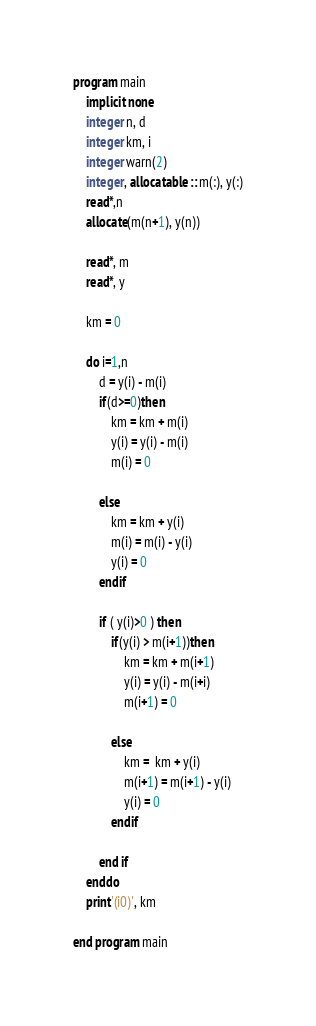<code> <loc_0><loc_0><loc_500><loc_500><_FORTRAN_>program main
    implicit none
    integer n, d
    integer km, i
    integer warn(2)
    integer, allocatable :: m(:), y(:)
    read*,n
    allocate(m(n+1), y(n))

    read*, m
    read*, y

    km = 0

    do i=1,n
        d = y(i) - m(i)
        if(d>=0)then
            km = km + m(i)
            y(i) = y(i) - m(i)
            m(i) = 0

        else
            km = km + y(i)
            m(i) = m(i) - y(i)
            y(i) = 0
        endif

        if ( y(i)>0 ) then
            if(y(i) > m(i+1))then
                km = km + m(i+1) 
                y(i) = y(i) - m(i+i)
                m(i+1) = 0
            
            else
                km =  km + y(i)
                m(i+1) = m(i+1) - y(i)
                y(i) = 0
            endif
            
        end if
    enddo
    print'(i0)', km
  
end program main</code> 